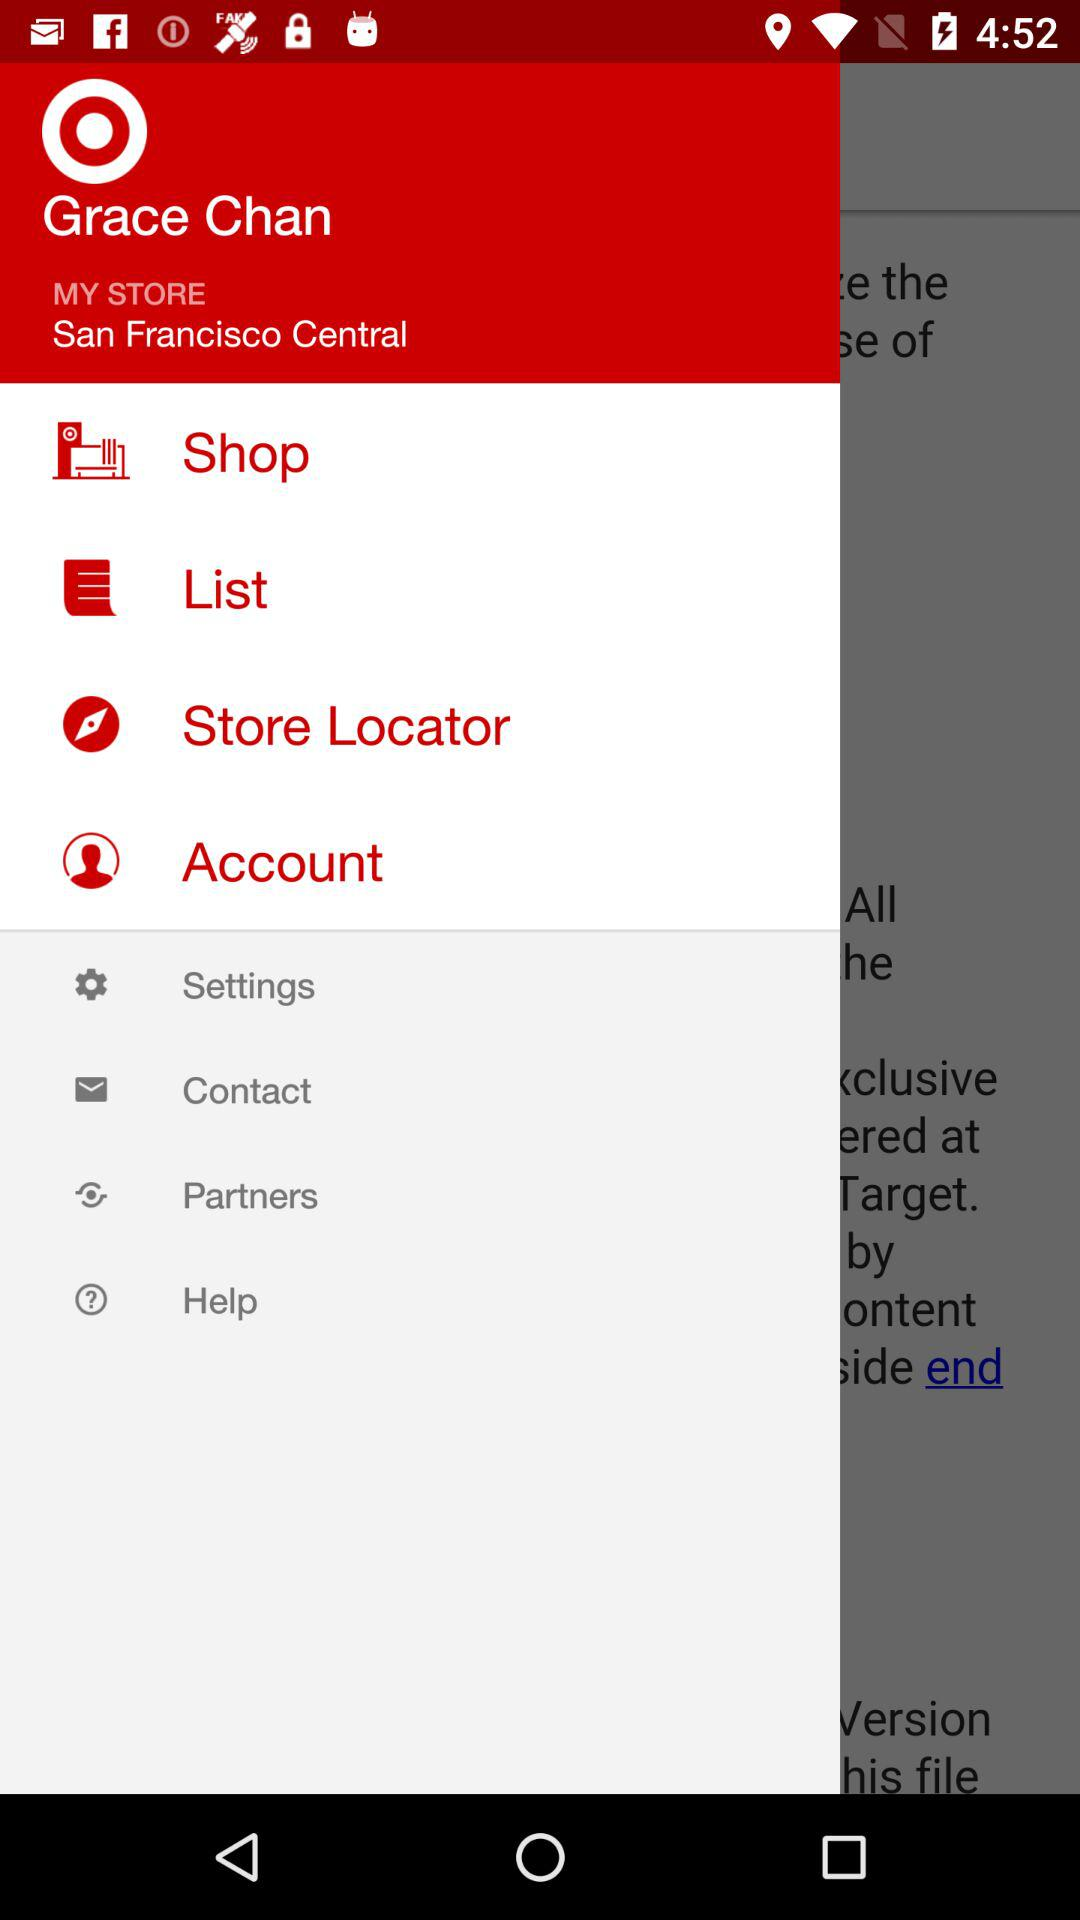What is the given location? The given location is San Francisco Central. 